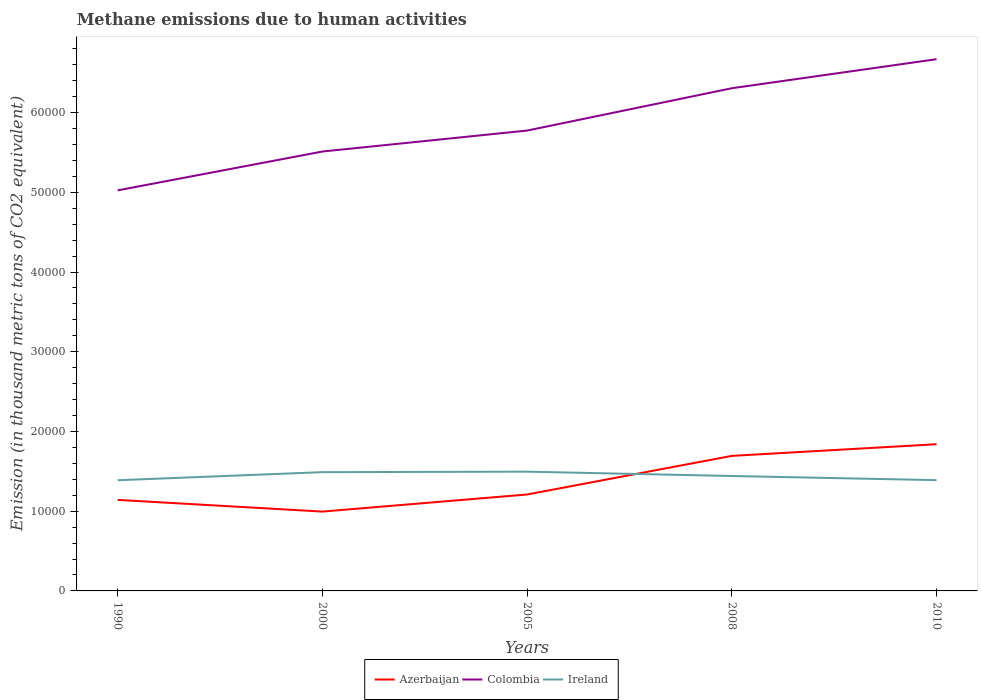How many different coloured lines are there?
Offer a terse response. 3. Does the line corresponding to Colombia intersect with the line corresponding to Ireland?
Provide a short and direct response. No. Is the number of lines equal to the number of legend labels?
Offer a terse response. Yes. Across all years, what is the maximum amount of methane emitted in Azerbaijan?
Provide a succinct answer. 9950.9. In which year was the amount of methane emitted in Colombia maximum?
Keep it short and to the point. 1990. What is the total amount of methane emitted in Ireland in the graph?
Provide a short and direct response. -11.6. What is the difference between the highest and the second highest amount of methane emitted in Colombia?
Offer a terse response. 1.65e+04. What is the difference between the highest and the lowest amount of methane emitted in Azerbaijan?
Your response must be concise. 2. Is the amount of methane emitted in Azerbaijan strictly greater than the amount of methane emitted in Colombia over the years?
Give a very brief answer. Yes. Does the graph contain any zero values?
Keep it short and to the point. No. Does the graph contain grids?
Offer a very short reply. No. Where does the legend appear in the graph?
Ensure brevity in your answer.  Bottom center. How many legend labels are there?
Offer a terse response. 3. How are the legend labels stacked?
Make the answer very short. Horizontal. What is the title of the graph?
Keep it short and to the point. Methane emissions due to human activities. What is the label or title of the Y-axis?
Give a very brief answer. Emission (in thousand metric tons of CO2 equivalent). What is the Emission (in thousand metric tons of CO2 equivalent) in Azerbaijan in 1990?
Make the answer very short. 1.14e+04. What is the Emission (in thousand metric tons of CO2 equivalent) in Colombia in 1990?
Your response must be concise. 5.02e+04. What is the Emission (in thousand metric tons of CO2 equivalent) in Ireland in 1990?
Your answer should be very brief. 1.39e+04. What is the Emission (in thousand metric tons of CO2 equivalent) of Azerbaijan in 2000?
Give a very brief answer. 9950.9. What is the Emission (in thousand metric tons of CO2 equivalent) of Colombia in 2000?
Offer a very short reply. 5.51e+04. What is the Emission (in thousand metric tons of CO2 equivalent) of Ireland in 2000?
Ensure brevity in your answer.  1.49e+04. What is the Emission (in thousand metric tons of CO2 equivalent) in Azerbaijan in 2005?
Give a very brief answer. 1.21e+04. What is the Emission (in thousand metric tons of CO2 equivalent) in Colombia in 2005?
Offer a terse response. 5.77e+04. What is the Emission (in thousand metric tons of CO2 equivalent) in Ireland in 2005?
Provide a succinct answer. 1.50e+04. What is the Emission (in thousand metric tons of CO2 equivalent) of Azerbaijan in 2008?
Your answer should be very brief. 1.69e+04. What is the Emission (in thousand metric tons of CO2 equivalent) of Colombia in 2008?
Your answer should be very brief. 6.31e+04. What is the Emission (in thousand metric tons of CO2 equivalent) of Ireland in 2008?
Your answer should be compact. 1.44e+04. What is the Emission (in thousand metric tons of CO2 equivalent) of Azerbaijan in 2010?
Keep it short and to the point. 1.84e+04. What is the Emission (in thousand metric tons of CO2 equivalent) in Colombia in 2010?
Ensure brevity in your answer.  6.67e+04. What is the Emission (in thousand metric tons of CO2 equivalent) in Ireland in 2010?
Ensure brevity in your answer.  1.39e+04. Across all years, what is the maximum Emission (in thousand metric tons of CO2 equivalent) of Azerbaijan?
Your answer should be very brief. 1.84e+04. Across all years, what is the maximum Emission (in thousand metric tons of CO2 equivalent) in Colombia?
Provide a succinct answer. 6.67e+04. Across all years, what is the maximum Emission (in thousand metric tons of CO2 equivalent) of Ireland?
Ensure brevity in your answer.  1.50e+04. Across all years, what is the minimum Emission (in thousand metric tons of CO2 equivalent) of Azerbaijan?
Your answer should be very brief. 9950.9. Across all years, what is the minimum Emission (in thousand metric tons of CO2 equivalent) in Colombia?
Offer a very short reply. 5.02e+04. Across all years, what is the minimum Emission (in thousand metric tons of CO2 equivalent) in Ireland?
Give a very brief answer. 1.39e+04. What is the total Emission (in thousand metric tons of CO2 equivalent) of Azerbaijan in the graph?
Provide a short and direct response. 6.88e+04. What is the total Emission (in thousand metric tons of CO2 equivalent) of Colombia in the graph?
Ensure brevity in your answer.  2.93e+05. What is the total Emission (in thousand metric tons of CO2 equivalent) in Ireland in the graph?
Ensure brevity in your answer.  7.21e+04. What is the difference between the Emission (in thousand metric tons of CO2 equivalent) in Azerbaijan in 1990 and that in 2000?
Offer a terse response. 1467.3. What is the difference between the Emission (in thousand metric tons of CO2 equivalent) of Colombia in 1990 and that in 2000?
Your answer should be compact. -4870.6. What is the difference between the Emission (in thousand metric tons of CO2 equivalent) in Ireland in 1990 and that in 2000?
Keep it short and to the point. -1013.1. What is the difference between the Emission (in thousand metric tons of CO2 equivalent) in Azerbaijan in 1990 and that in 2005?
Make the answer very short. -678.1. What is the difference between the Emission (in thousand metric tons of CO2 equivalent) of Colombia in 1990 and that in 2005?
Your answer should be compact. -7500.3. What is the difference between the Emission (in thousand metric tons of CO2 equivalent) of Ireland in 1990 and that in 2005?
Make the answer very short. -1076.2. What is the difference between the Emission (in thousand metric tons of CO2 equivalent) of Azerbaijan in 1990 and that in 2008?
Give a very brief answer. -5520.9. What is the difference between the Emission (in thousand metric tons of CO2 equivalent) of Colombia in 1990 and that in 2008?
Your response must be concise. -1.28e+04. What is the difference between the Emission (in thousand metric tons of CO2 equivalent) in Ireland in 1990 and that in 2008?
Your response must be concise. -531.2. What is the difference between the Emission (in thousand metric tons of CO2 equivalent) in Azerbaijan in 1990 and that in 2010?
Your answer should be compact. -6982.3. What is the difference between the Emission (in thousand metric tons of CO2 equivalent) in Colombia in 1990 and that in 2010?
Your response must be concise. -1.65e+04. What is the difference between the Emission (in thousand metric tons of CO2 equivalent) in Ireland in 1990 and that in 2010?
Keep it short and to the point. -11.6. What is the difference between the Emission (in thousand metric tons of CO2 equivalent) in Azerbaijan in 2000 and that in 2005?
Make the answer very short. -2145.4. What is the difference between the Emission (in thousand metric tons of CO2 equivalent) in Colombia in 2000 and that in 2005?
Ensure brevity in your answer.  -2629.7. What is the difference between the Emission (in thousand metric tons of CO2 equivalent) in Ireland in 2000 and that in 2005?
Give a very brief answer. -63.1. What is the difference between the Emission (in thousand metric tons of CO2 equivalent) in Azerbaijan in 2000 and that in 2008?
Make the answer very short. -6988.2. What is the difference between the Emission (in thousand metric tons of CO2 equivalent) in Colombia in 2000 and that in 2008?
Ensure brevity in your answer.  -7940.3. What is the difference between the Emission (in thousand metric tons of CO2 equivalent) in Ireland in 2000 and that in 2008?
Your answer should be compact. 481.9. What is the difference between the Emission (in thousand metric tons of CO2 equivalent) of Azerbaijan in 2000 and that in 2010?
Your answer should be very brief. -8449.6. What is the difference between the Emission (in thousand metric tons of CO2 equivalent) in Colombia in 2000 and that in 2010?
Provide a short and direct response. -1.16e+04. What is the difference between the Emission (in thousand metric tons of CO2 equivalent) in Ireland in 2000 and that in 2010?
Give a very brief answer. 1001.5. What is the difference between the Emission (in thousand metric tons of CO2 equivalent) in Azerbaijan in 2005 and that in 2008?
Offer a terse response. -4842.8. What is the difference between the Emission (in thousand metric tons of CO2 equivalent) in Colombia in 2005 and that in 2008?
Provide a succinct answer. -5310.6. What is the difference between the Emission (in thousand metric tons of CO2 equivalent) in Ireland in 2005 and that in 2008?
Provide a short and direct response. 545. What is the difference between the Emission (in thousand metric tons of CO2 equivalent) in Azerbaijan in 2005 and that in 2010?
Your answer should be compact. -6304.2. What is the difference between the Emission (in thousand metric tons of CO2 equivalent) of Colombia in 2005 and that in 2010?
Offer a very short reply. -8951.6. What is the difference between the Emission (in thousand metric tons of CO2 equivalent) of Ireland in 2005 and that in 2010?
Provide a short and direct response. 1064.6. What is the difference between the Emission (in thousand metric tons of CO2 equivalent) of Azerbaijan in 2008 and that in 2010?
Your answer should be very brief. -1461.4. What is the difference between the Emission (in thousand metric tons of CO2 equivalent) in Colombia in 2008 and that in 2010?
Provide a short and direct response. -3641. What is the difference between the Emission (in thousand metric tons of CO2 equivalent) in Ireland in 2008 and that in 2010?
Your response must be concise. 519.6. What is the difference between the Emission (in thousand metric tons of CO2 equivalent) in Azerbaijan in 1990 and the Emission (in thousand metric tons of CO2 equivalent) in Colombia in 2000?
Give a very brief answer. -4.37e+04. What is the difference between the Emission (in thousand metric tons of CO2 equivalent) in Azerbaijan in 1990 and the Emission (in thousand metric tons of CO2 equivalent) in Ireland in 2000?
Your answer should be very brief. -3478.8. What is the difference between the Emission (in thousand metric tons of CO2 equivalent) in Colombia in 1990 and the Emission (in thousand metric tons of CO2 equivalent) in Ireland in 2000?
Your response must be concise. 3.53e+04. What is the difference between the Emission (in thousand metric tons of CO2 equivalent) of Azerbaijan in 1990 and the Emission (in thousand metric tons of CO2 equivalent) of Colombia in 2005?
Keep it short and to the point. -4.63e+04. What is the difference between the Emission (in thousand metric tons of CO2 equivalent) of Azerbaijan in 1990 and the Emission (in thousand metric tons of CO2 equivalent) of Ireland in 2005?
Provide a short and direct response. -3541.9. What is the difference between the Emission (in thousand metric tons of CO2 equivalent) in Colombia in 1990 and the Emission (in thousand metric tons of CO2 equivalent) in Ireland in 2005?
Your response must be concise. 3.53e+04. What is the difference between the Emission (in thousand metric tons of CO2 equivalent) in Azerbaijan in 1990 and the Emission (in thousand metric tons of CO2 equivalent) in Colombia in 2008?
Your answer should be compact. -5.16e+04. What is the difference between the Emission (in thousand metric tons of CO2 equivalent) in Azerbaijan in 1990 and the Emission (in thousand metric tons of CO2 equivalent) in Ireland in 2008?
Ensure brevity in your answer.  -2996.9. What is the difference between the Emission (in thousand metric tons of CO2 equivalent) of Colombia in 1990 and the Emission (in thousand metric tons of CO2 equivalent) of Ireland in 2008?
Your answer should be compact. 3.58e+04. What is the difference between the Emission (in thousand metric tons of CO2 equivalent) in Azerbaijan in 1990 and the Emission (in thousand metric tons of CO2 equivalent) in Colombia in 2010?
Provide a short and direct response. -5.53e+04. What is the difference between the Emission (in thousand metric tons of CO2 equivalent) in Azerbaijan in 1990 and the Emission (in thousand metric tons of CO2 equivalent) in Ireland in 2010?
Your answer should be compact. -2477.3. What is the difference between the Emission (in thousand metric tons of CO2 equivalent) of Colombia in 1990 and the Emission (in thousand metric tons of CO2 equivalent) of Ireland in 2010?
Your answer should be compact. 3.63e+04. What is the difference between the Emission (in thousand metric tons of CO2 equivalent) in Azerbaijan in 2000 and the Emission (in thousand metric tons of CO2 equivalent) in Colombia in 2005?
Ensure brevity in your answer.  -4.78e+04. What is the difference between the Emission (in thousand metric tons of CO2 equivalent) of Azerbaijan in 2000 and the Emission (in thousand metric tons of CO2 equivalent) of Ireland in 2005?
Your response must be concise. -5009.2. What is the difference between the Emission (in thousand metric tons of CO2 equivalent) in Colombia in 2000 and the Emission (in thousand metric tons of CO2 equivalent) in Ireland in 2005?
Make the answer very short. 4.02e+04. What is the difference between the Emission (in thousand metric tons of CO2 equivalent) in Azerbaijan in 2000 and the Emission (in thousand metric tons of CO2 equivalent) in Colombia in 2008?
Provide a succinct answer. -5.31e+04. What is the difference between the Emission (in thousand metric tons of CO2 equivalent) of Azerbaijan in 2000 and the Emission (in thousand metric tons of CO2 equivalent) of Ireland in 2008?
Your response must be concise. -4464.2. What is the difference between the Emission (in thousand metric tons of CO2 equivalent) of Colombia in 2000 and the Emission (in thousand metric tons of CO2 equivalent) of Ireland in 2008?
Provide a succinct answer. 4.07e+04. What is the difference between the Emission (in thousand metric tons of CO2 equivalent) of Azerbaijan in 2000 and the Emission (in thousand metric tons of CO2 equivalent) of Colombia in 2010?
Your answer should be compact. -5.67e+04. What is the difference between the Emission (in thousand metric tons of CO2 equivalent) in Azerbaijan in 2000 and the Emission (in thousand metric tons of CO2 equivalent) in Ireland in 2010?
Offer a terse response. -3944.6. What is the difference between the Emission (in thousand metric tons of CO2 equivalent) in Colombia in 2000 and the Emission (in thousand metric tons of CO2 equivalent) in Ireland in 2010?
Provide a succinct answer. 4.12e+04. What is the difference between the Emission (in thousand metric tons of CO2 equivalent) in Azerbaijan in 2005 and the Emission (in thousand metric tons of CO2 equivalent) in Colombia in 2008?
Keep it short and to the point. -5.10e+04. What is the difference between the Emission (in thousand metric tons of CO2 equivalent) of Azerbaijan in 2005 and the Emission (in thousand metric tons of CO2 equivalent) of Ireland in 2008?
Make the answer very short. -2318.8. What is the difference between the Emission (in thousand metric tons of CO2 equivalent) in Colombia in 2005 and the Emission (in thousand metric tons of CO2 equivalent) in Ireland in 2008?
Your answer should be compact. 4.33e+04. What is the difference between the Emission (in thousand metric tons of CO2 equivalent) of Azerbaijan in 2005 and the Emission (in thousand metric tons of CO2 equivalent) of Colombia in 2010?
Your response must be concise. -5.46e+04. What is the difference between the Emission (in thousand metric tons of CO2 equivalent) in Azerbaijan in 2005 and the Emission (in thousand metric tons of CO2 equivalent) in Ireland in 2010?
Provide a short and direct response. -1799.2. What is the difference between the Emission (in thousand metric tons of CO2 equivalent) of Colombia in 2005 and the Emission (in thousand metric tons of CO2 equivalent) of Ireland in 2010?
Your response must be concise. 4.38e+04. What is the difference between the Emission (in thousand metric tons of CO2 equivalent) of Azerbaijan in 2008 and the Emission (in thousand metric tons of CO2 equivalent) of Colombia in 2010?
Keep it short and to the point. -4.98e+04. What is the difference between the Emission (in thousand metric tons of CO2 equivalent) in Azerbaijan in 2008 and the Emission (in thousand metric tons of CO2 equivalent) in Ireland in 2010?
Your response must be concise. 3043.6. What is the difference between the Emission (in thousand metric tons of CO2 equivalent) of Colombia in 2008 and the Emission (in thousand metric tons of CO2 equivalent) of Ireland in 2010?
Make the answer very short. 4.92e+04. What is the average Emission (in thousand metric tons of CO2 equivalent) in Azerbaijan per year?
Offer a very short reply. 1.38e+04. What is the average Emission (in thousand metric tons of CO2 equivalent) in Colombia per year?
Keep it short and to the point. 5.86e+04. What is the average Emission (in thousand metric tons of CO2 equivalent) of Ireland per year?
Your answer should be very brief. 1.44e+04. In the year 1990, what is the difference between the Emission (in thousand metric tons of CO2 equivalent) in Azerbaijan and Emission (in thousand metric tons of CO2 equivalent) in Colombia?
Provide a succinct answer. -3.88e+04. In the year 1990, what is the difference between the Emission (in thousand metric tons of CO2 equivalent) in Azerbaijan and Emission (in thousand metric tons of CO2 equivalent) in Ireland?
Ensure brevity in your answer.  -2465.7. In the year 1990, what is the difference between the Emission (in thousand metric tons of CO2 equivalent) of Colombia and Emission (in thousand metric tons of CO2 equivalent) of Ireland?
Your response must be concise. 3.64e+04. In the year 2000, what is the difference between the Emission (in thousand metric tons of CO2 equivalent) of Azerbaijan and Emission (in thousand metric tons of CO2 equivalent) of Colombia?
Provide a succinct answer. -4.52e+04. In the year 2000, what is the difference between the Emission (in thousand metric tons of CO2 equivalent) in Azerbaijan and Emission (in thousand metric tons of CO2 equivalent) in Ireland?
Offer a terse response. -4946.1. In the year 2000, what is the difference between the Emission (in thousand metric tons of CO2 equivalent) in Colombia and Emission (in thousand metric tons of CO2 equivalent) in Ireland?
Provide a succinct answer. 4.02e+04. In the year 2005, what is the difference between the Emission (in thousand metric tons of CO2 equivalent) in Azerbaijan and Emission (in thousand metric tons of CO2 equivalent) in Colombia?
Make the answer very short. -4.56e+04. In the year 2005, what is the difference between the Emission (in thousand metric tons of CO2 equivalent) in Azerbaijan and Emission (in thousand metric tons of CO2 equivalent) in Ireland?
Offer a terse response. -2863.8. In the year 2005, what is the difference between the Emission (in thousand metric tons of CO2 equivalent) in Colombia and Emission (in thousand metric tons of CO2 equivalent) in Ireland?
Give a very brief answer. 4.28e+04. In the year 2008, what is the difference between the Emission (in thousand metric tons of CO2 equivalent) in Azerbaijan and Emission (in thousand metric tons of CO2 equivalent) in Colombia?
Your answer should be compact. -4.61e+04. In the year 2008, what is the difference between the Emission (in thousand metric tons of CO2 equivalent) of Azerbaijan and Emission (in thousand metric tons of CO2 equivalent) of Ireland?
Offer a terse response. 2524. In the year 2008, what is the difference between the Emission (in thousand metric tons of CO2 equivalent) of Colombia and Emission (in thousand metric tons of CO2 equivalent) of Ireland?
Provide a short and direct response. 4.86e+04. In the year 2010, what is the difference between the Emission (in thousand metric tons of CO2 equivalent) in Azerbaijan and Emission (in thousand metric tons of CO2 equivalent) in Colombia?
Your response must be concise. -4.83e+04. In the year 2010, what is the difference between the Emission (in thousand metric tons of CO2 equivalent) of Azerbaijan and Emission (in thousand metric tons of CO2 equivalent) of Ireland?
Your answer should be very brief. 4505. In the year 2010, what is the difference between the Emission (in thousand metric tons of CO2 equivalent) of Colombia and Emission (in thousand metric tons of CO2 equivalent) of Ireland?
Offer a terse response. 5.28e+04. What is the ratio of the Emission (in thousand metric tons of CO2 equivalent) of Azerbaijan in 1990 to that in 2000?
Offer a terse response. 1.15. What is the ratio of the Emission (in thousand metric tons of CO2 equivalent) in Colombia in 1990 to that in 2000?
Keep it short and to the point. 0.91. What is the ratio of the Emission (in thousand metric tons of CO2 equivalent) in Ireland in 1990 to that in 2000?
Offer a very short reply. 0.93. What is the ratio of the Emission (in thousand metric tons of CO2 equivalent) of Azerbaijan in 1990 to that in 2005?
Give a very brief answer. 0.94. What is the ratio of the Emission (in thousand metric tons of CO2 equivalent) of Colombia in 1990 to that in 2005?
Ensure brevity in your answer.  0.87. What is the ratio of the Emission (in thousand metric tons of CO2 equivalent) in Ireland in 1990 to that in 2005?
Your answer should be very brief. 0.93. What is the ratio of the Emission (in thousand metric tons of CO2 equivalent) of Azerbaijan in 1990 to that in 2008?
Give a very brief answer. 0.67. What is the ratio of the Emission (in thousand metric tons of CO2 equivalent) of Colombia in 1990 to that in 2008?
Your answer should be very brief. 0.8. What is the ratio of the Emission (in thousand metric tons of CO2 equivalent) in Ireland in 1990 to that in 2008?
Your answer should be compact. 0.96. What is the ratio of the Emission (in thousand metric tons of CO2 equivalent) of Azerbaijan in 1990 to that in 2010?
Provide a succinct answer. 0.62. What is the ratio of the Emission (in thousand metric tons of CO2 equivalent) of Colombia in 1990 to that in 2010?
Provide a short and direct response. 0.75. What is the ratio of the Emission (in thousand metric tons of CO2 equivalent) in Azerbaijan in 2000 to that in 2005?
Ensure brevity in your answer.  0.82. What is the ratio of the Emission (in thousand metric tons of CO2 equivalent) of Colombia in 2000 to that in 2005?
Your response must be concise. 0.95. What is the ratio of the Emission (in thousand metric tons of CO2 equivalent) of Azerbaijan in 2000 to that in 2008?
Ensure brevity in your answer.  0.59. What is the ratio of the Emission (in thousand metric tons of CO2 equivalent) in Colombia in 2000 to that in 2008?
Make the answer very short. 0.87. What is the ratio of the Emission (in thousand metric tons of CO2 equivalent) in Ireland in 2000 to that in 2008?
Keep it short and to the point. 1.03. What is the ratio of the Emission (in thousand metric tons of CO2 equivalent) of Azerbaijan in 2000 to that in 2010?
Offer a terse response. 0.54. What is the ratio of the Emission (in thousand metric tons of CO2 equivalent) of Colombia in 2000 to that in 2010?
Your answer should be compact. 0.83. What is the ratio of the Emission (in thousand metric tons of CO2 equivalent) in Ireland in 2000 to that in 2010?
Give a very brief answer. 1.07. What is the ratio of the Emission (in thousand metric tons of CO2 equivalent) of Azerbaijan in 2005 to that in 2008?
Offer a terse response. 0.71. What is the ratio of the Emission (in thousand metric tons of CO2 equivalent) in Colombia in 2005 to that in 2008?
Make the answer very short. 0.92. What is the ratio of the Emission (in thousand metric tons of CO2 equivalent) in Ireland in 2005 to that in 2008?
Give a very brief answer. 1.04. What is the ratio of the Emission (in thousand metric tons of CO2 equivalent) of Azerbaijan in 2005 to that in 2010?
Your answer should be compact. 0.66. What is the ratio of the Emission (in thousand metric tons of CO2 equivalent) of Colombia in 2005 to that in 2010?
Ensure brevity in your answer.  0.87. What is the ratio of the Emission (in thousand metric tons of CO2 equivalent) in Ireland in 2005 to that in 2010?
Your answer should be very brief. 1.08. What is the ratio of the Emission (in thousand metric tons of CO2 equivalent) in Azerbaijan in 2008 to that in 2010?
Give a very brief answer. 0.92. What is the ratio of the Emission (in thousand metric tons of CO2 equivalent) in Colombia in 2008 to that in 2010?
Make the answer very short. 0.95. What is the ratio of the Emission (in thousand metric tons of CO2 equivalent) in Ireland in 2008 to that in 2010?
Provide a short and direct response. 1.04. What is the difference between the highest and the second highest Emission (in thousand metric tons of CO2 equivalent) of Azerbaijan?
Provide a succinct answer. 1461.4. What is the difference between the highest and the second highest Emission (in thousand metric tons of CO2 equivalent) in Colombia?
Offer a very short reply. 3641. What is the difference between the highest and the second highest Emission (in thousand metric tons of CO2 equivalent) of Ireland?
Ensure brevity in your answer.  63.1. What is the difference between the highest and the lowest Emission (in thousand metric tons of CO2 equivalent) in Azerbaijan?
Offer a very short reply. 8449.6. What is the difference between the highest and the lowest Emission (in thousand metric tons of CO2 equivalent) in Colombia?
Offer a very short reply. 1.65e+04. What is the difference between the highest and the lowest Emission (in thousand metric tons of CO2 equivalent) of Ireland?
Your answer should be very brief. 1076.2. 